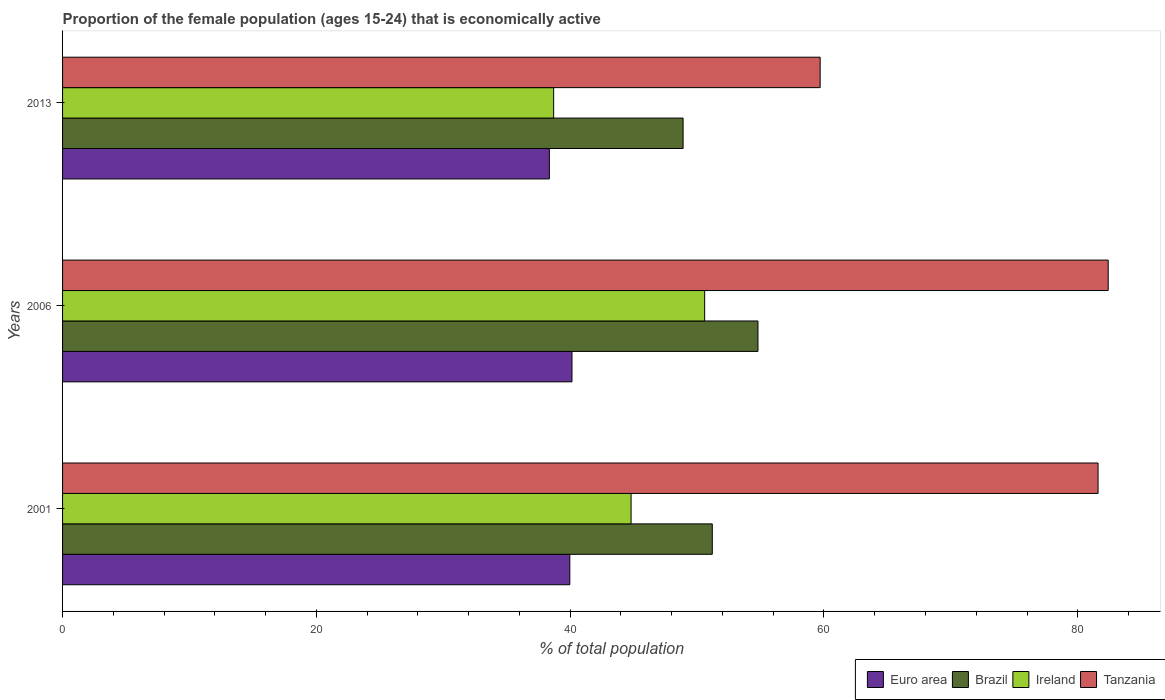How many different coloured bars are there?
Provide a short and direct response. 4. Are the number of bars per tick equal to the number of legend labels?
Make the answer very short. Yes. How many bars are there on the 3rd tick from the top?
Keep it short and to the point. 4. How many bars are there on the 3rd tick from the bottom?
Ensure brevity in your answer.  4. In how many cases, is the number of bars for a given year not equal to the number of legend labels?
Ensure brevity in your answer.  0. What is the proportion of the female population that is economically active in Ireland in 2006?
Make the answer very short. 50.6. Across all years, what is the maximum proportion of the female population that is economically active in Brazil?
Provide a short and direct response. 54.8. Across all years, what is the minimum proportion of the female population that is economically active in Ireland?
Your response must be concise. 38.7. In which year was the proportion of the female population that is economically active in Ireland maximum?
Your answer should be compact. 2006. What is the total proportion of the female population that is economically active in Tanzania in the graph?
Your answer should be compact. 223.7. What is the difference between the proportion of the female population that is economically active in Brazil in 2001 and that in 2006?
Give a very brief answer. -3.6. What is the difference between the proportion of the female population that is economically active in Euro area in 2006 and the proportion of the female population that is economically active in Tanzania in 2001?
Your response must be concise. -41.46. What is the average proportion of the female population that is economically active in Tanzania per year?
Give a very brief answer. 74.57. In the year 2013, what is the difference between the proportion of the female population that is economically active in Tanzania and proportion of the female population that is economically active in Brazil?
Give a very brief answer. 10.8. In how many years, is the proportion of the female population that is economically active in Ireland greater than 68 %?
Offer a very short reply. 0. What is the ratio of the proportion of the female population that is economically active in Tanzania in 2006 to that in 2013?
Offer a terse response. 1.38. Is the difference between the proportion of the female population that is economically active in Tanzania in 2006 and 2013 greater than the difference between the proportion of the female population that is economically active in Brazil in 2006 and 2013?
Provide a succinct answer. Yes. What is the difference between the highest and the second highest proportion of the female population that is economically active in Euro area?
Ensure brevity in your answer.  0.17. What is the difference between the highest and the lowest proportion of the female population that is economically active in Tanzania?
Provide a succinct answer. 22.7. In how many years, is the proportion of the female population that is economically active in Euro area greater than the average proportion of the female population that is economically active in Euro area taken over all years?
Make the answer very short. 2. What does the 3rd bar from the top in 2001 represents?
Your answer should be compact. Brazil. What does the 3rd bar from the bottom in 2006 represents?
Keep it short and to the point. Ireland. Is it the case that in every year, the sum of the proportion of the female population that is economically active in Brazil and proportion of the female population that is economically active in Tanzania is greater than the proportion of the female population that is economically active in Euro area?
Your response must be concise. Yes. How many bars are there?
Keep it short and to the point. 12. Are all the bars in the graph horizontal?
Your answer should be very brief. Yes. How many years are there in the graph?
Your response must be concise. 3. What is the difference between two consecutive major ticks on the X-axis?
Offer a terse response. 20. Are the values on the major ticks of X-axis written in scientific E-notation?
Provide a succinct answer. No. Does the graph contain any zero values?
Give a very brief answer. No. Does the graph contain grids?
Your answer should be compact. No. How are the legend labels stacked?
Provide a succinct answer. Horizontal. What is the title of the graph?
Provide a short and direct response. Proportion of the female population (ages 15-24) that is economically active. What is the label or title of the X-axis?
Offer a terse response. % of total population. What is the % of total population in Euro area in 2001?
Offer a very short reply. 39.97. What is the % of total population in Brazil in 2001?
Provide a short and direct response. 51.2. What is the % of total population in Ireland in 2001?
Make the answer very short. 44.8. What is the % of total population of Tanzania in 2001?
Provide a short and direct response. 81.6. What is the % of total population in Euro area in 2006?
Your response must be concise. 40.14. What is the % of total population of Brazil in 2006?
Offer a terse response. 54.8. What is the % of total population in Ireland in 2006?
Give a very brief answer. 50.6. What is the % of total population of Tanzania in 2006?
Your response must be concise. 82.4. What is the % of total population of Euro area in 2013?
Provide a succinct answer. 38.36. What is the % of total population of Brazil in 2013?
Ensure brevity in your answer.  48.9. What is the % of total population of Ireland in 2013?
Give a very brief answer. 38.7. What is the % of total population in Tanzania in 2013?
Provide a short and direct response. 59.7. Across all years, what is the maximum % of total population of Euro area?
Your response must be concise. 40.14. Across all years, what is the maximum % of total population of Brazil?
Make the answer very short. 54.8. Across all years, what is the maximum % of total population of Ireland?
Ensure brevity in your answer.  50.6. Across all years, what is the maximum % of total population in Tanzania?
Provide a succinct answer. 82.4. Across all years, what is the minimum % of total population of Euro area?
Your answer should be compact. 38.36. Across all years, what is the minimum % of total population in Brazil?
Provide a succinct answer. 48.9. Across all years, what is the minimum % of total population of Ireland?
Keep it short and to the point. 38.7. Across all years, what is the minimum % of total population of Tanzania?
Provide a short and direct response. 59.7. What is the total % of total population in Euro area in the graph?
Offer a terse response. 118.48. What is the total % of total population in Brazil in the graph?
Offer a terse response. 154.9. What is the total % of total population of Ireland in the graph?
Give a very brief answer. 134.1. What is the total % of total population in Tanzania in the graph?
Provide a short and direct response. 223.7. What is the difference between the % of total population in Euro area in 2001 and that in 2006?
Give a very brief answer. -0.17. What is the difference between the % of total population of Brazil in 2001 and that in 2006?
Offer a terse response. -3.6. What is the difference between the % of total population in Ireland in 2001 and that in 2006?
Give a very brief answer. -5.8. What is the difference between the % of total population of Tanzania in 2001 and that in 2006?
Your answer should be compact. -0.8. What is the difference between the % of total population in Euro area in 2001 and that in 2013?
Provide a succinct answer. 1.61. What is the difference between the % of total population of Brazil in 2001 and that in 2013?
Provide a short and direct response. 2.3. What is the difference between the % of total population in Ireland in 2001 and that in 2013?
Give a very brief answer. 6.1. What is the difference between the % of total population in Tanzania in 2001 and that in 2013?
Offer a terse response. 21.9. What is the difference between the % of total population of Euro area in 2006 and that in 2013?
Keep it short and to the point. 1.78. What is the difference between the % of total population of Brazil in 2006 and that in 2013?
Make the answer very short. 5.9. What is the difference between the % of total population of Ireland in 2006 and that in 2013?
Provide a short and direct response. 11.9. What is the difference between the % of total population in Tanzania in 2006 and that in 2013?
Give a very brief answer. 22.7. What is the difference between the % of total population of Euro area in 2001 and the % of total population of Brazil in 2006?
Your response must be concise. -14.83. What is the difference between the % of total population in Euro area in 2001 and the % of total population in Ireland in 2006?
Your answer should be very brief. -10.63. What is the difference between the % of total population of Euro area in 2001 and the % of total population of Tanzania in 2006?
Offer a terse response. -42.43. What is the difference between the % of total population of Brazil in 2001 and the % of total population of Ireland in 2006?
Keep it short and to the point. 0.6. What is the difference between the % of total population in Brazil in 2001 and the % of total population in Tanzania in 2006?
Provide a short and direct response. -31.2. What is the difference between the % of total population in Ireland in 2001 and the % of total population in Tanzania in 2006?
Your response must be concise. -37.6. What is the difference between the % of total population of Euro area in 2001 and the % of total population of Brazil in 2013?
Provide a succinct answer. -8.93. What is the difference between the % of total population of Euro area in 2001 and the % of total population of Ireland in 2013?
Your response must be concise. 1.27. What is the difference between the % of total population of Euro area in 2001 and the % of total population of Tanzania in 2013?
Give a very brief answer. -19.73. What is the difference between the % of total population of Brazil in 2001 and the % of total population of Ireland in 2013?
Give a very brief answer. 12.5. What is the difference between the % of total population in Brazil in 2001 and the % of total population in Tanzania in 2013?
Offer a very short reply. -8.5. What is the difference between the % of total population in Ireland in 2001 and the % of total population in Tanzania in 2013?
Your answer should be compact. -14.9. What is the difference between the % of total population of Euro area in 2006 and the % of total population of Brazil in 2013?
Ensure brevity in your answer.  -8.76. What is the difference between the % of total population in Euro area in 2006 and the % of total population in Ireland in 2013?
Ensure brevity in your answer.  1.44. What is the difference between the % of total population in Euro area in 2006 and the % of total population in Tanzania in 2013?
Keep it short and to the point. -19.56. What is the difference between the % of total population in Brazil in 2006 and the % of total population in Ireland in 2013?
Your answer should be very brief. 16.1. What is the difference between the % of total population of Ireland in 2006 and the % of total population of Tanzania in 2013?
Provide a short and direct response. -9.1. What is the average % of total population in Euro area per year?
Your response must be concise. 39.49. What is the average % of total population in Brazil per year?
Give a very brief answer. 51.63. What is the average % of total population of Ireland per year?
Your response must be concise. 44.7. What is the average % of total population in Tanzania per year?
Your answer should be very brief. 74.57. In the year 2001, what is the difference between the % of total population in Euro area and % of total population in Brazil?
Offer a terse response. -11.23. In the year 2001, what is the difference between the % of total population in Euro area and % of total population in Ireland?
Keep it short and to the point. -4.83. In the year 2001, what is the difference between the % of total population in Euro area and % of total population in Tanzania?
Keep it short and to the point. -41.63. In the year 2001, what is the difference between the % of total population in Brazil and % of total population in Tanzania?
Give a very brief answer. -30.4. In the year 2001, what is the difference between the % of total population in Ireland and % of total population in Tanzania?
Your answer should be compact. -36.8. In the year 2006, what is the difference between the % of total population of Euro area and % of total population of Brazil?
Make the answer very short. -14.66. In the year 2006, what is the difference between the % of total population in Euro area and % of total population in Ireland?
Offer a terse response. -10.46. In the year 2006, what is the difference between the % of total population of Euro area and % of total population of Tanzania?
Ensure brevity in your answer.  -42.26. In the year 2006, what is the difference between the % of total population in Brazil and % of total population in Ireland?
Offer a terse response. 4.2. In the year 2006, what is the difference between the % of total population in Brazil and % of total population in Tanzania?
Ensure brevity in your answer.  -27.6. In the year 2006, what is the difference between the % of total population of Ireland and % of total population of Tanzania?
Ensure brevity in your answer.  -31.8. In the year 2013, what is the difference between the % of total population in Euro area and % of total population in Brazil?
Provide a short and direct response. -10.54. In the year 2013, what is the difference between the % of total population in Euro area and % of total population in Ireland?
Provide a short and direct response. -0.34. In the year 2013, what is the difference between the % of total population in Euro area and % of total population in Tanzania?
Keep it short and to the point. -21.34. In the year 2013, what is the difference between the % of total population in Ireland and % of total population in Tanzania?
Offer a very short reply. -21. What is the ratio of the % of total population of Euro area in 2001 to that in 2006?
Your answer should be compact. 1. What is the ratio of the % of total population of Brazil in 2001 to that in 2006?
Your answer should be very brief. 0.93. What is the ratio of the % of total population of Ireland in 2001 to that in 2006?
Keep it short and to the point. 0.89. What is the ratio of the % of total population in Tanzania in 2001 to that in 2006?
Ensure brevity in your answer.  0.99. What is the ratio of the % of total population in Euro area in 2001 to that in 2013?
Keep it short and to the point. 1.04. What is the ratio of the % of total population of Brazil in 2001 to that in 2013?
Your answer should be very brief. 1.05. What is the ratio of the % of total population in Ireland in 2001 to that in 2013?
Your response must be concise. 1.16. What is the ratio of the % of total population of Tanzania in 2001 to that in 2013?
Give a very brief answer. 1.37. What is the ratio of the % of total population in Euro area in 2006 to that in 2013?
Offer a terse response. 1.05. What is the ratio of the % of total population in Brazil in 2006 to that in 2013?
Make the answer very short. 1.12. What is the ratio of the % of total population in Ireland in 2006 to that in 2013?
Provide a short and direct response. 1.31. What is the ratio of the % of total population in Tanzania in 2006 to that in 2013?
Offer a very short reply. 1.38. What is the difference between the highest and the second highest % of total population of Euro area?
Offer a terse response. 0.17. What is the difference between the highest and the second highest % of total population of Brazil?
Your answer should be compact. 3.6. What is the difference between the highest and the second highest % of total population in Tanzania?
Your answer should be compact. 0.8. What is the difference between the highest and the lowest % of total population in Euro area?
Provide a succinct answer. 1.78. What is the difference between the highest and the lowest % of total population of Ireland?
Offer a terse response. 11.9. What is the difference between the highest and the lowest % of total population in Tanzania?
Your response must be concise. 22.7. 